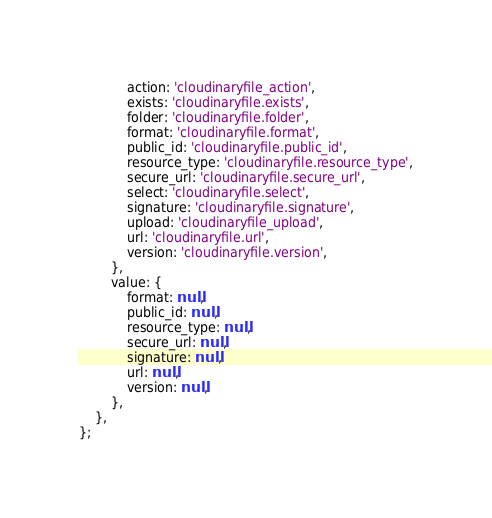Convert code to text. <code><loc_0><loc_0><loc_500><loc_500><_JavaScript_>			action: 'cloudinaryfile_action',
			exists: 'cloudinaryfile.exists',
			folder: 'cloudinaryfile.folder',
			format: 'cloudinaryfile.format',
			public_id: 'cloudinaryfile.public_id',
			resource_type: 'cloudinaryfile.resource_type',
			secure_url: 'cloudinaryfile.secure_url',
			select: 'cloudinaryfile.select',
			signature: 'cloudinaryfile.signature',
			upload: 'cloudinaryfile_upload',
			url: 'cloudinaryfile.url',
			version: 'cloudinaryfile.version',
		},
		value: {
			format: null,
			public_id: null,
			resource_type: null,
			secure_url: null,
			signature: null,
			url: null,
			version: null,
		},
	},
};
</code> 